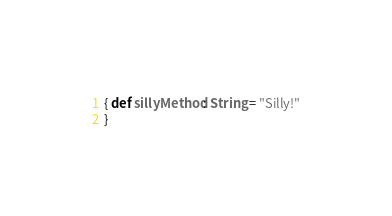<code> <loc_0><loc_0><loc_500><loc_500><_Scala_>{ def sillyMethod: String = "Silly!"
}</code> 